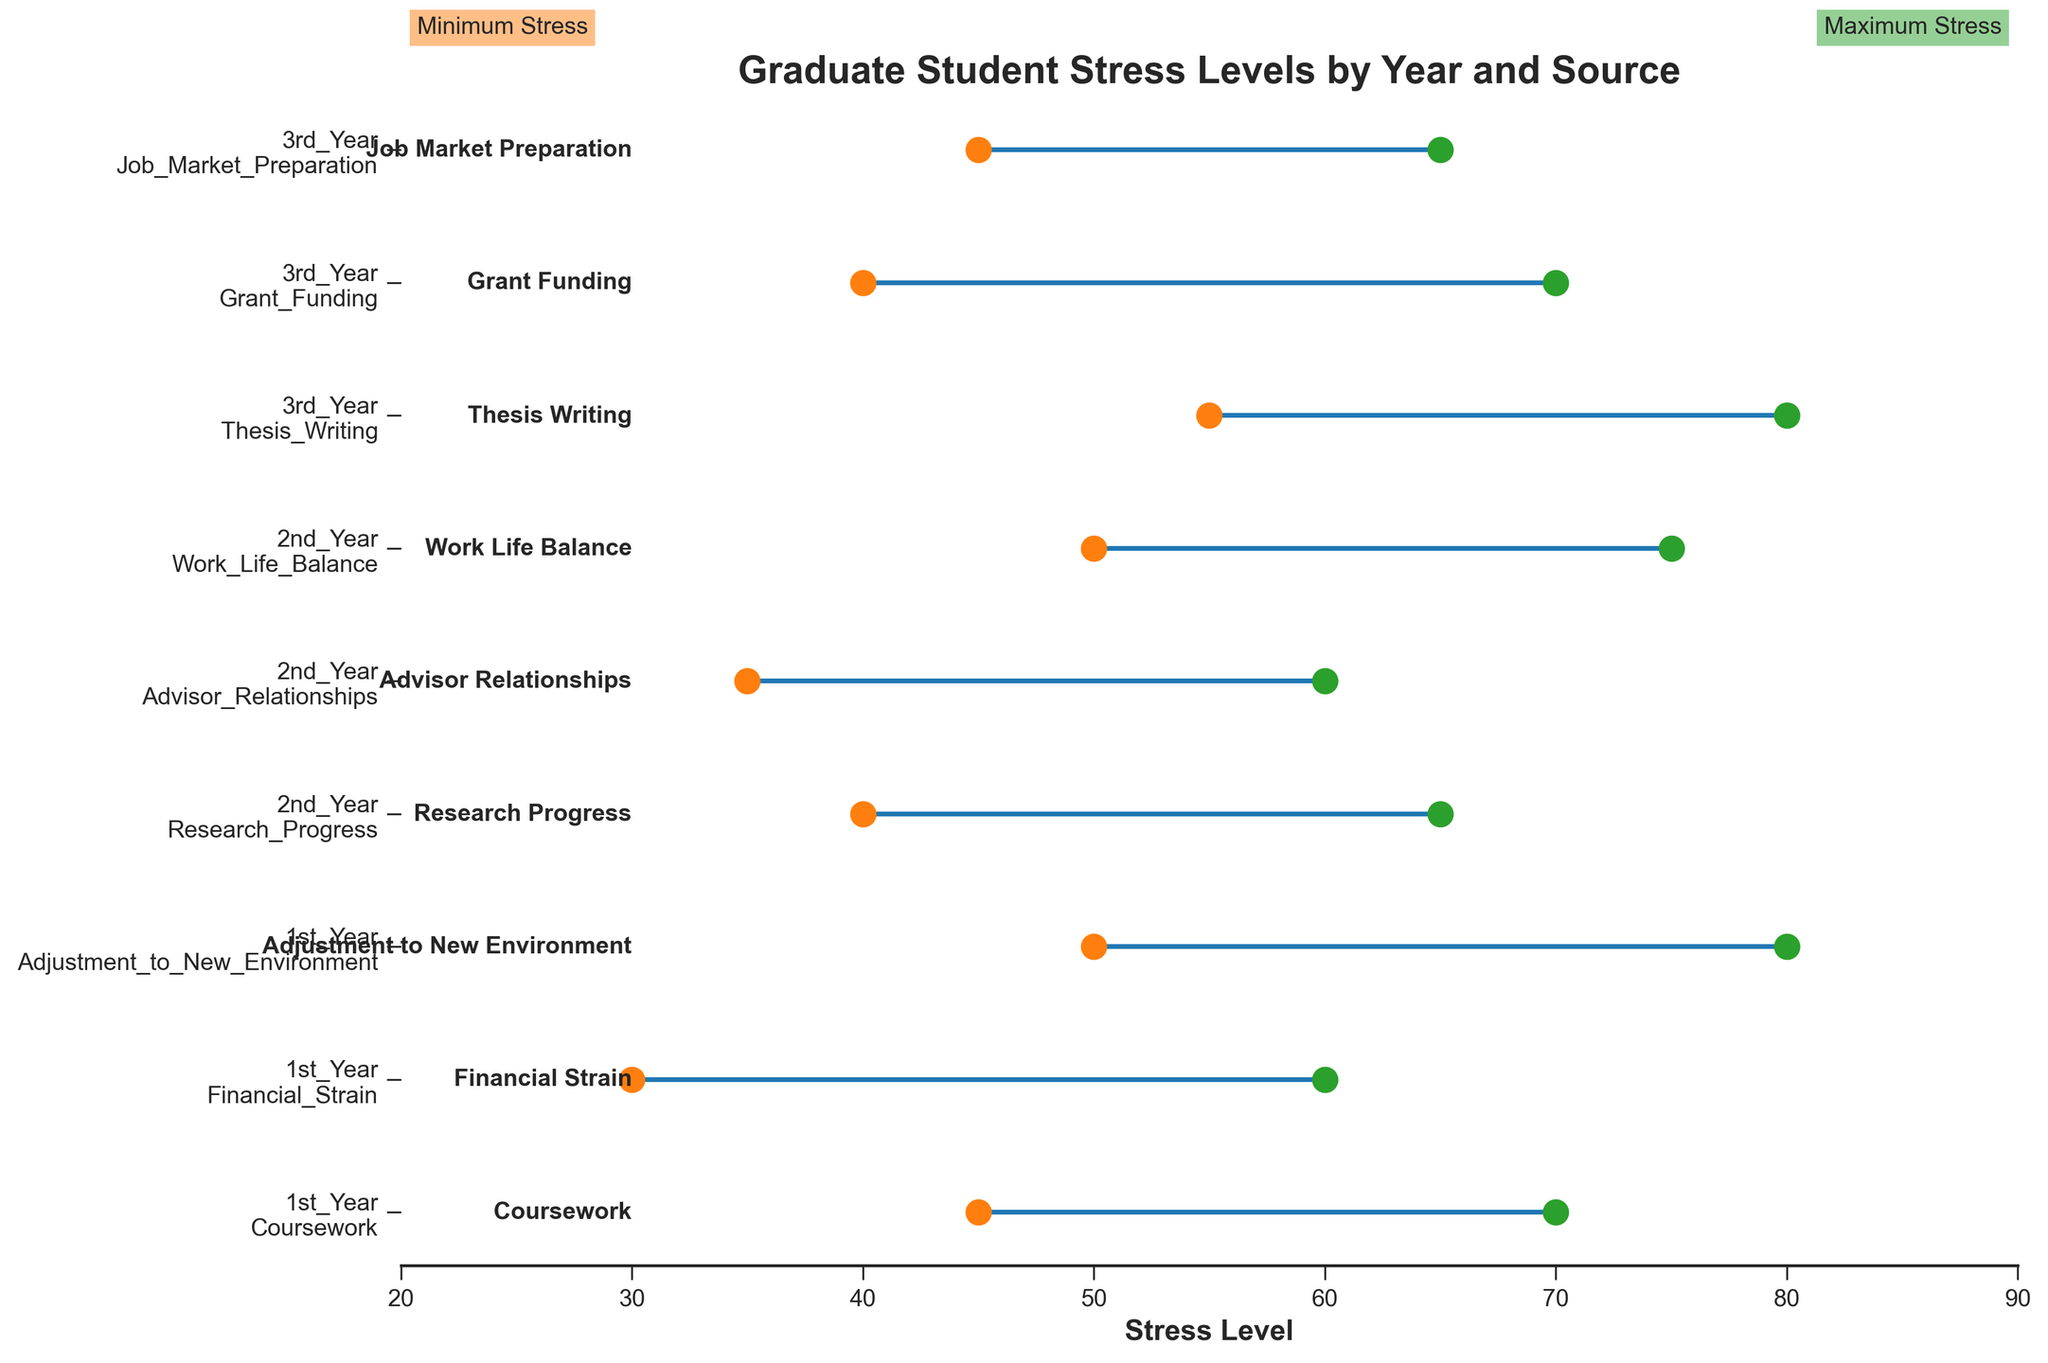What's the title of the figure? The title is typically displayed at the top of the figure. It describes the main theme or subject of the plot. According to the provided code, the title is "Graduate Student Stress Levels by Year and Source."
Answer: Graduate Student Stress Levels by Year and Source How are the minimum and maximum stress levels distinguished in the figure? To identify the minimum and maximum stress levels, we look for distinctive markers in the figure. According to the code, minimum stress levels are represented by orange markers and maximum stress levels by green markers.
Answer: Orange and green markers What is the primary source of stress with the highest maximum stress level for 3rd-year students? We examine the maximum stress levels for each primary source of stress listed under "3rd_Year." Thesis Writing has the highest maximum stress level of 80.
Answer: Thesis Writing Which academic year has the widest range of stress levels for any source of stress? To find this, we look for the largest difference between the minimum and maximum stress levels. Adjusting to New Environment in the 1st Year has the widest range of 30 units (80 - 50).
Answer: 1st Year What is the median max stress level for 2nd-year students? First, we list the maximum stress levels for 2nd-year students: 65, 60, and 75. Since there are three values, the median is the middle value when arranged in ascending order: 60, 65, 75.
Answer: 65 Which academic year has the highest average maximum stress level? To find this, we need to calculate the average maximum stress levels for each academic year:
- 1st Year: (70 + 60 + 80) / 3 = 70
- 2nd Year: (65 + 60 + 75) / 3 = 66.67
- 3rd Year: (80 + 70 + 65) / 3 = 71.67
Comparing these averages, 3rd Year has the highest value.
Answer: 3rd Year What is the source of stress with the smallest range in stress levels for any academic year? We identify the source of stress by calculating the range for each entry and finding the smallest range:
- Coursework (1st Year): 70 - 45 = 25
- Financial Strain (1st Year): 60 - 30 = 30
- Adjustment to New Environment (1st Year): 80 - 50 = 30
- Research Progress (2nd Year): 65 - 40 = 25
- Advisor Relationships (2nd Year): 60 - 35 = 25
- Work Life Balance (2nd Year): 75 - 50 = 25
- Thesis Writing (3rd Year): 80 - 55 = 25
- Grant Funding (3rd Year): 70 - 40 = 30
- Job Market Preparation (3rd Year): 65 - 45 = 20
Job Market Preparation for the 3rd Year has the smallest range of 20 units.
Answer: Job Market Preparation How many sources of stress are listed for each academic year? Based on the visual information, each academic year lists three sources of stress. Counting the entries for each academic year confirms this: 3 entries per year.
Answer: Three sources per year Which source of stress has both its maximum and minimum values above 50 for the 1st year? We look for sources of stress listed under "1st Year" with both minimum and maximum stress levels above 50:
- Coursework: Min = 45, Max = 70 (does not fulfill criteria)
- Financial Strain: Min = 30, Max = 60 (does not fulfill criteria)
- Adjustment to New Environment: Min = 50, Max = 80 (fulfills criteria)
Only Adjustment to New Environment meets this criterion.
Answer: Adjustment to New Environment 